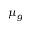Convert formula to latex. <formula><loc_0><loc_0><loc_500><loc_500>\mu _ { g }</formula> 